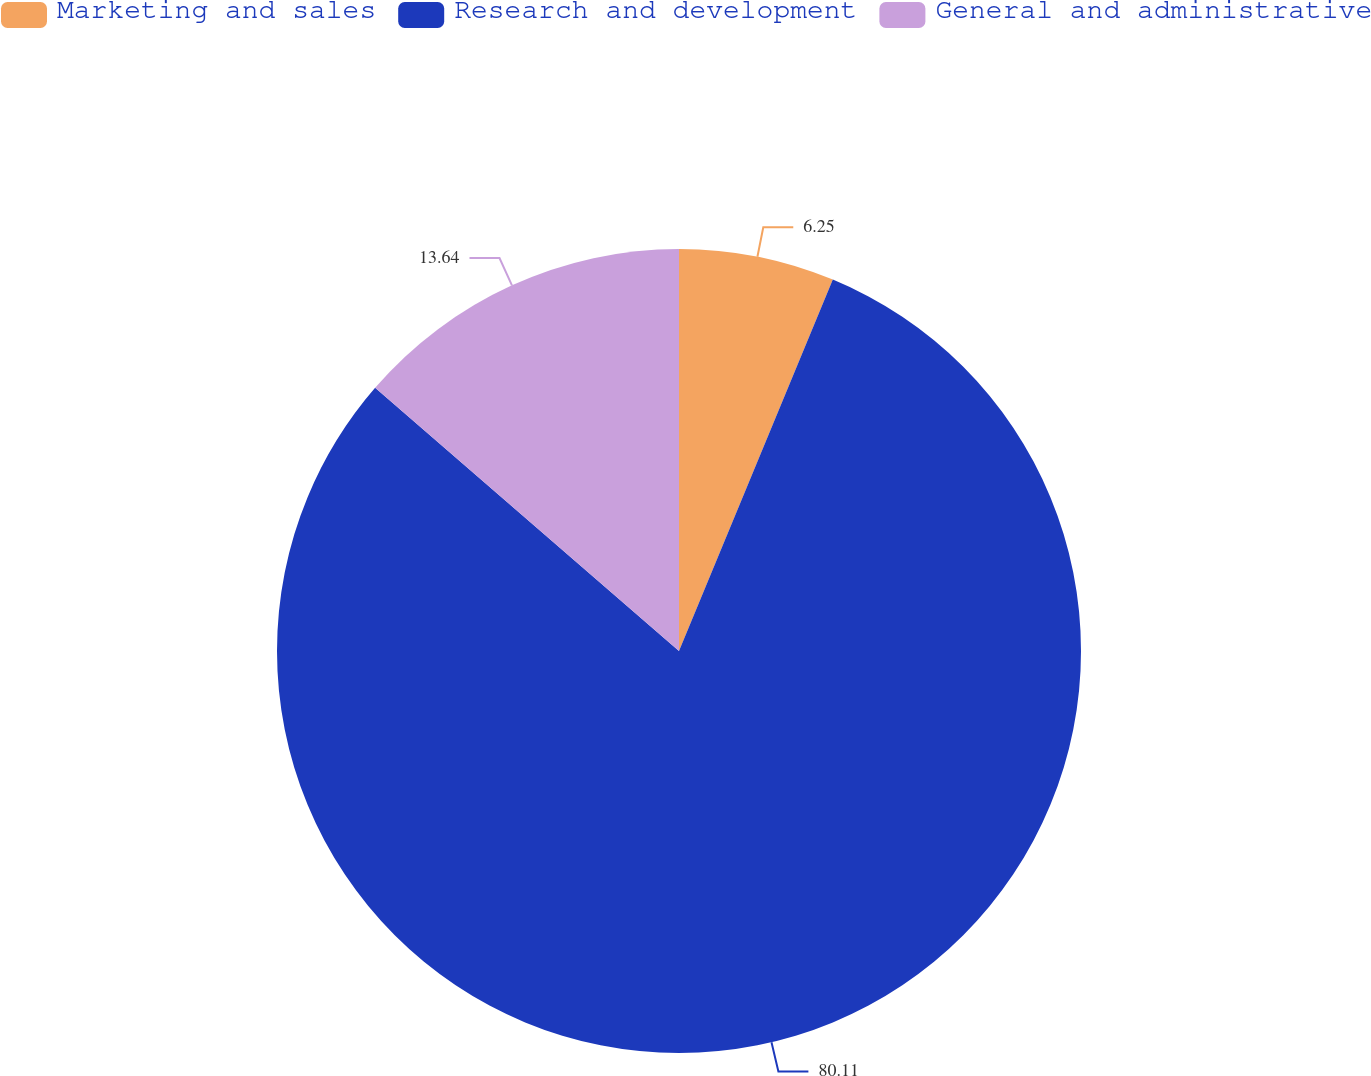Convert chart to OTSL. <chart><loc_0><loc_0><loc_500><loc_500><pie_chart><fcel>Marketing and sales<fcel>Research and development<fcel>General and administrative<nl><fcel>6.25%<fcel>80.11%<fcel>13.64%<nl></chart> 